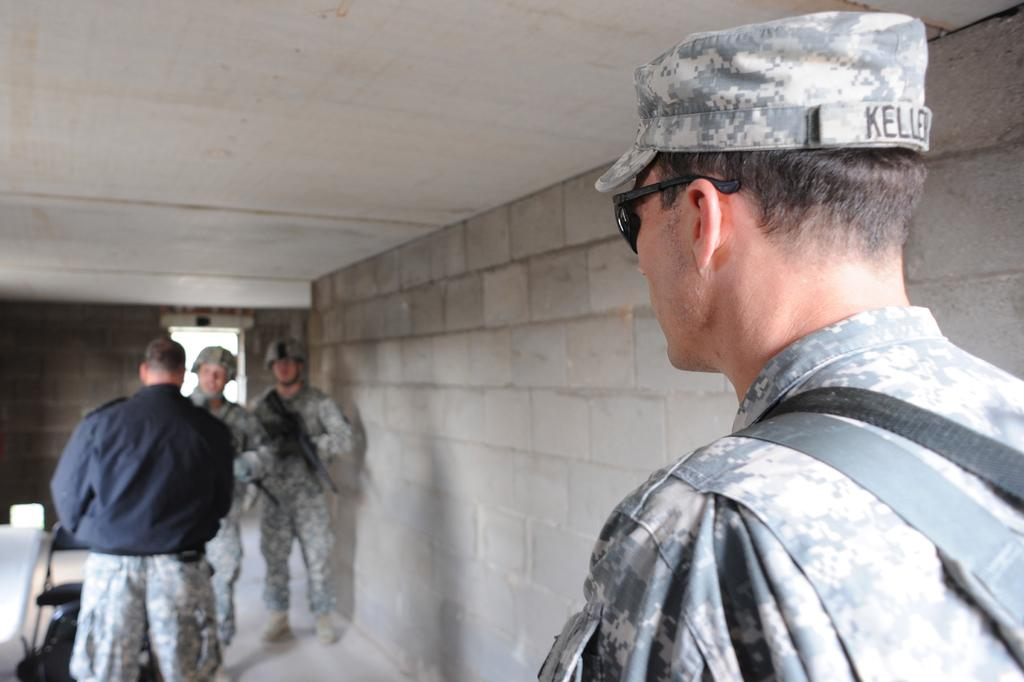What can be observed about the people in the room? There are people in the room, and they are wearing army uniforms. What are two of the people holding in their hands? Two people are holding guns in their hands. What is present on the floor in the room? There are objects on the floor. What type of humor can be seen in the image? There is no humor present in the image; it depicts people wearing army uniforms and holding guns. Can you describe the grass and trees in the image? There are no grass or trees present in the image. 